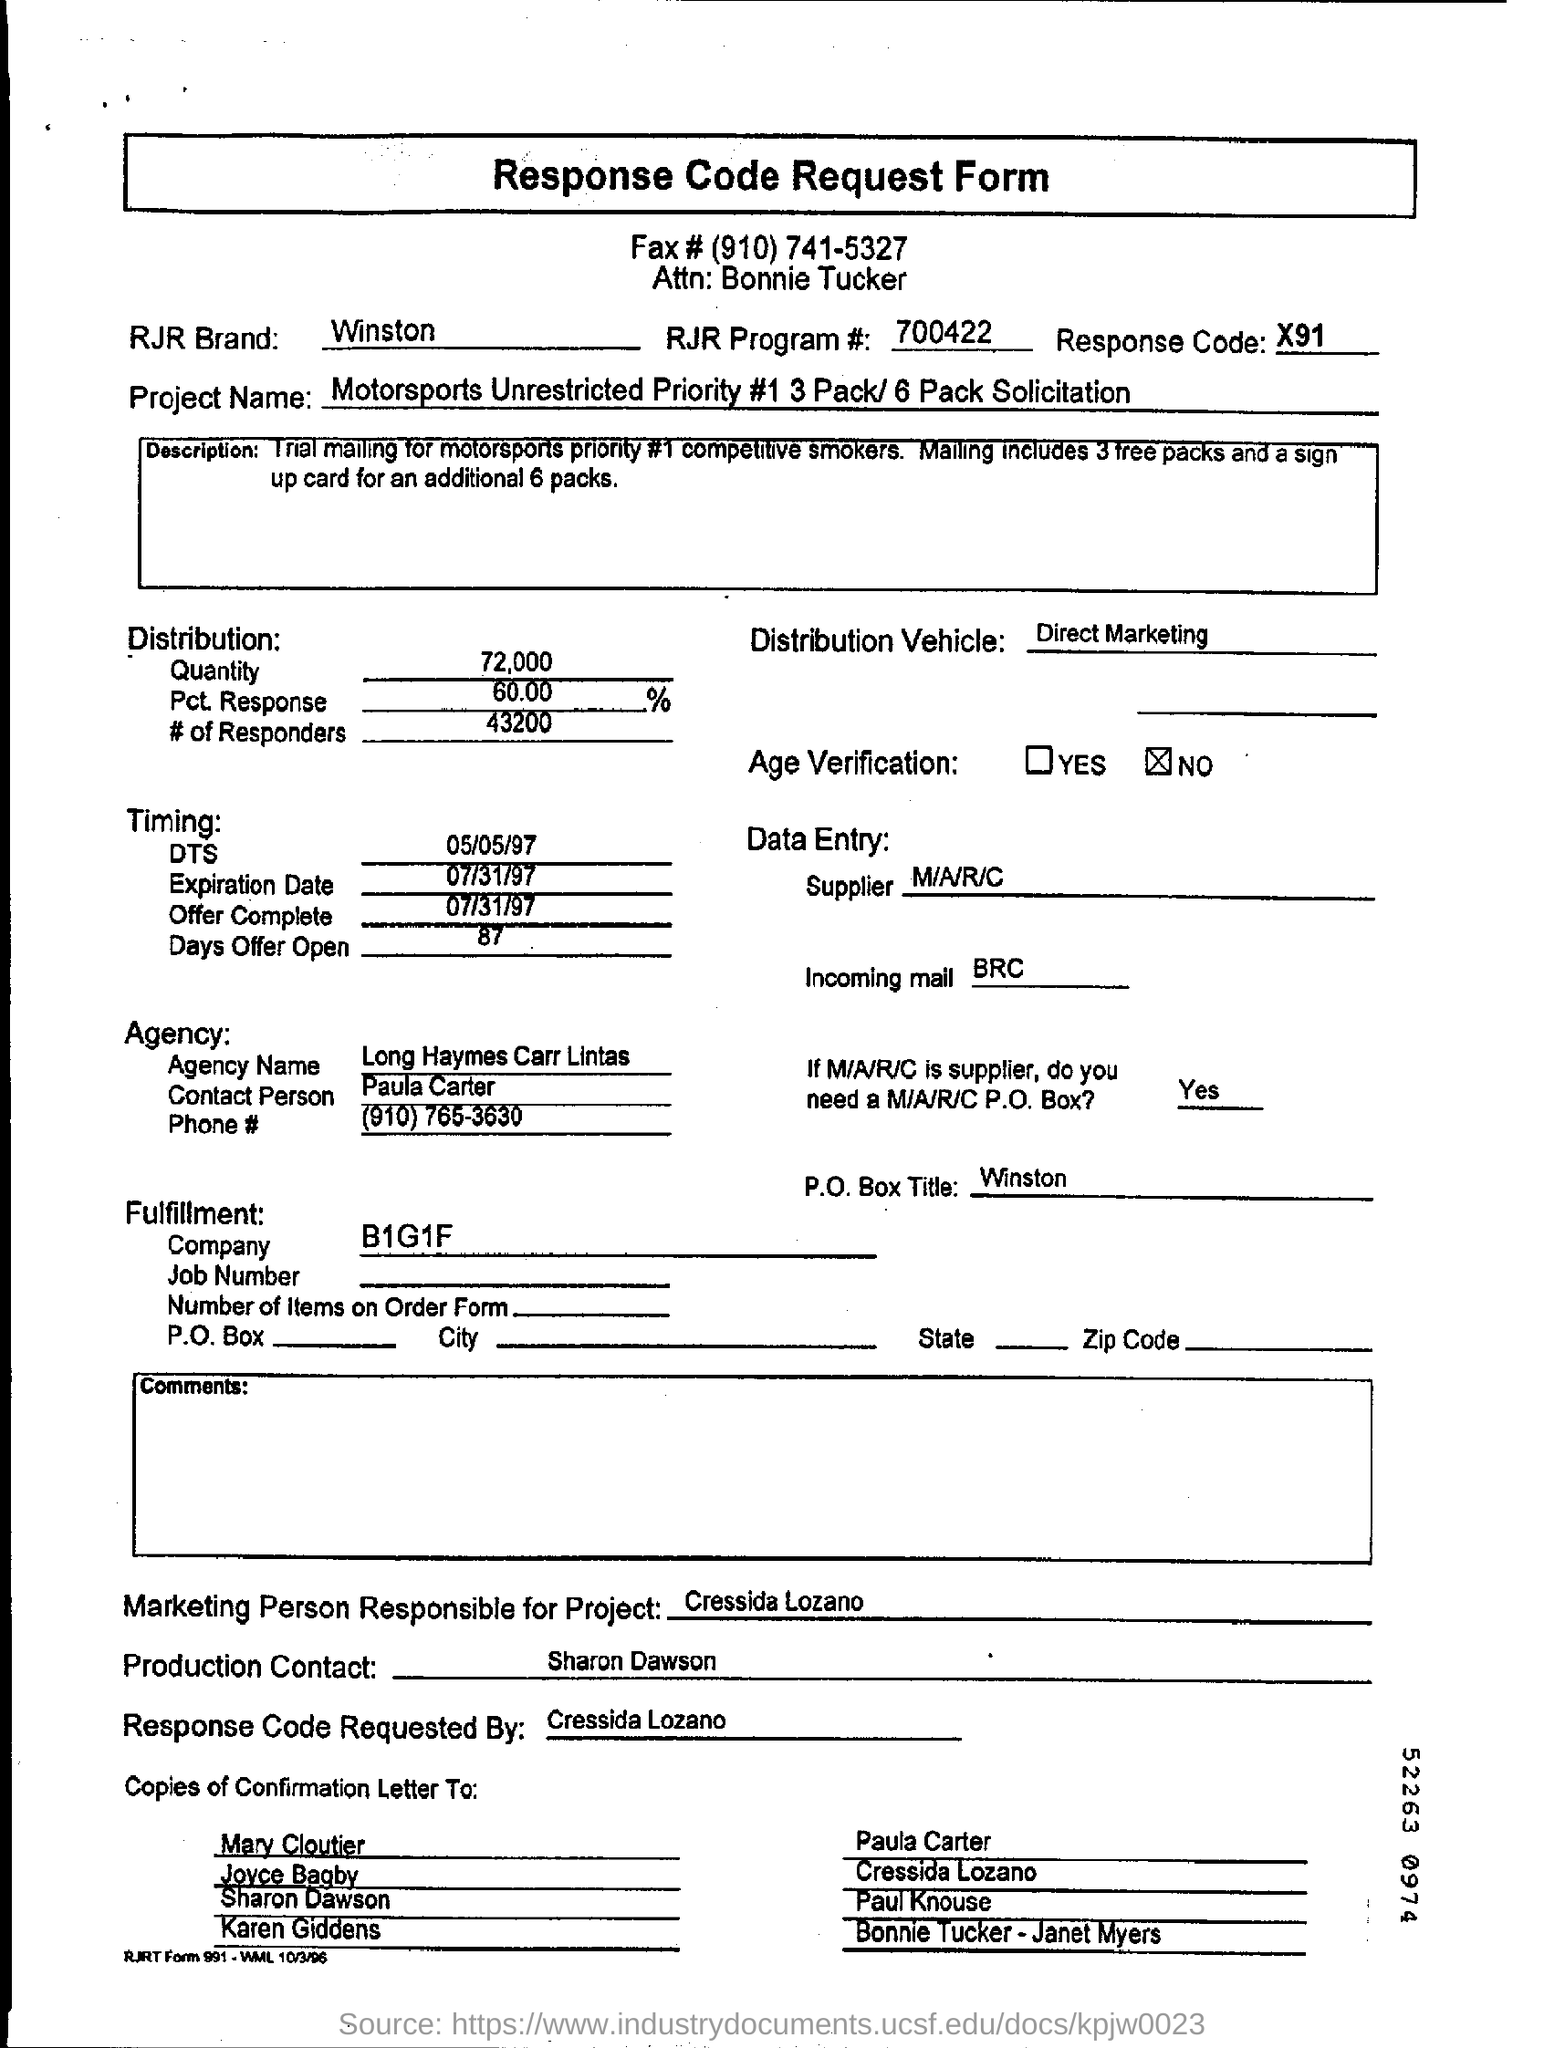what is the expiration date mentioned ?
 07/31/97 